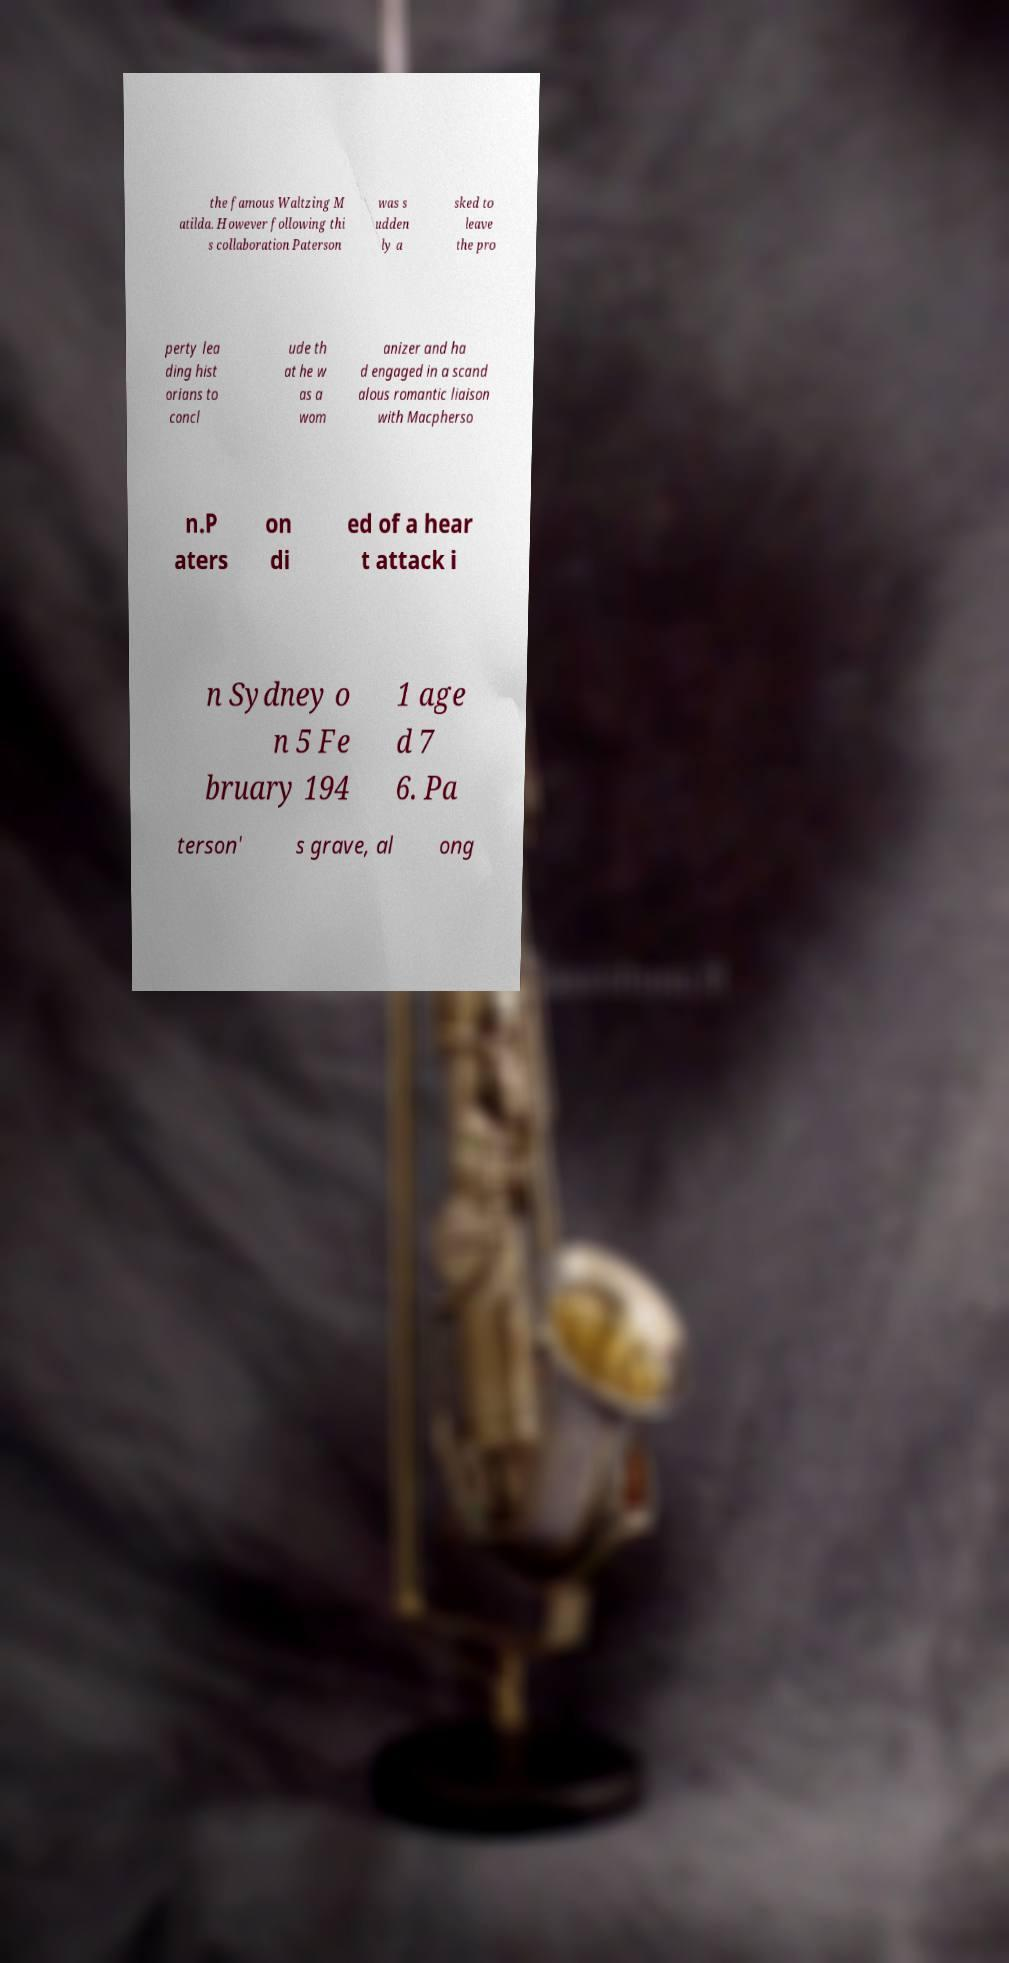Can you read and provide the text displayed in the image?This photo seems to have some interesting text. Can you extract and type it out for me? the famous Waltzing M atilda. However following thi s collaboration Paterson was s udden ly a sked to leave the pro perty lea ding hist orians to concl ude th at he w as a wom anizer and ha d engaged in a scand alous romantic liaison with Macpherso n.P aters on di ed of a hear t attack i n Sydney o n 5 Fe bruary 194 1 age d 7 6. Pa terson' s grave, al ong 